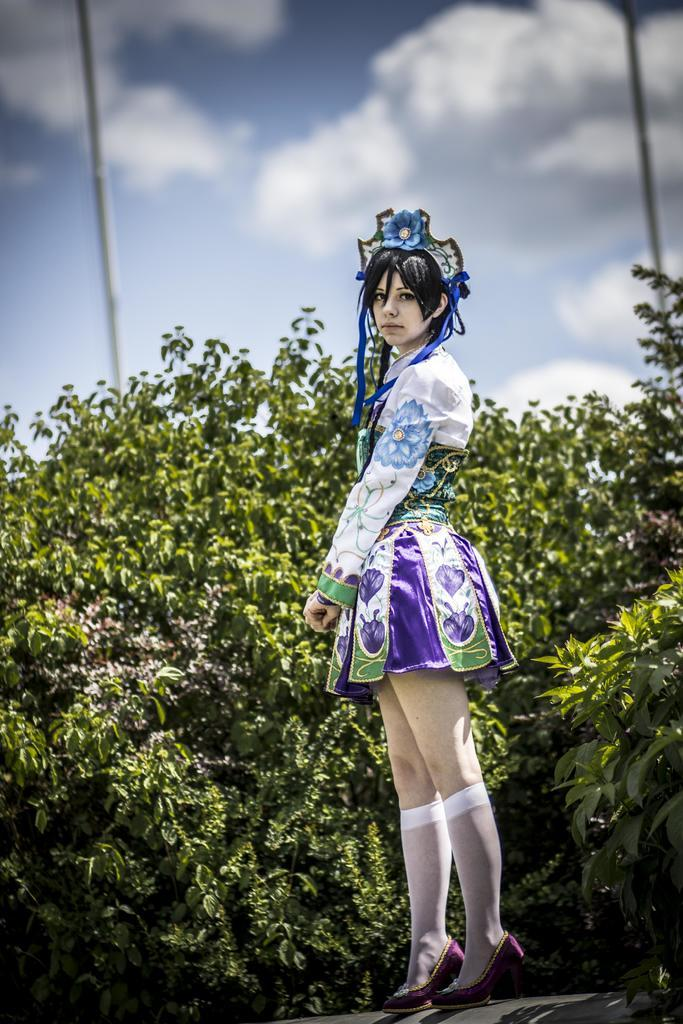Who is the main subject in the image? There is a lady standing in the center of the image. What is the lady wearing on her head? The lady is wearing a crown. What can be seen in the background of the image? There are trees, poles, and the sky visible in the background of the image. How is the sheet being distributed in the image? There is no sheet present in the image, so it cannot be distributed. 